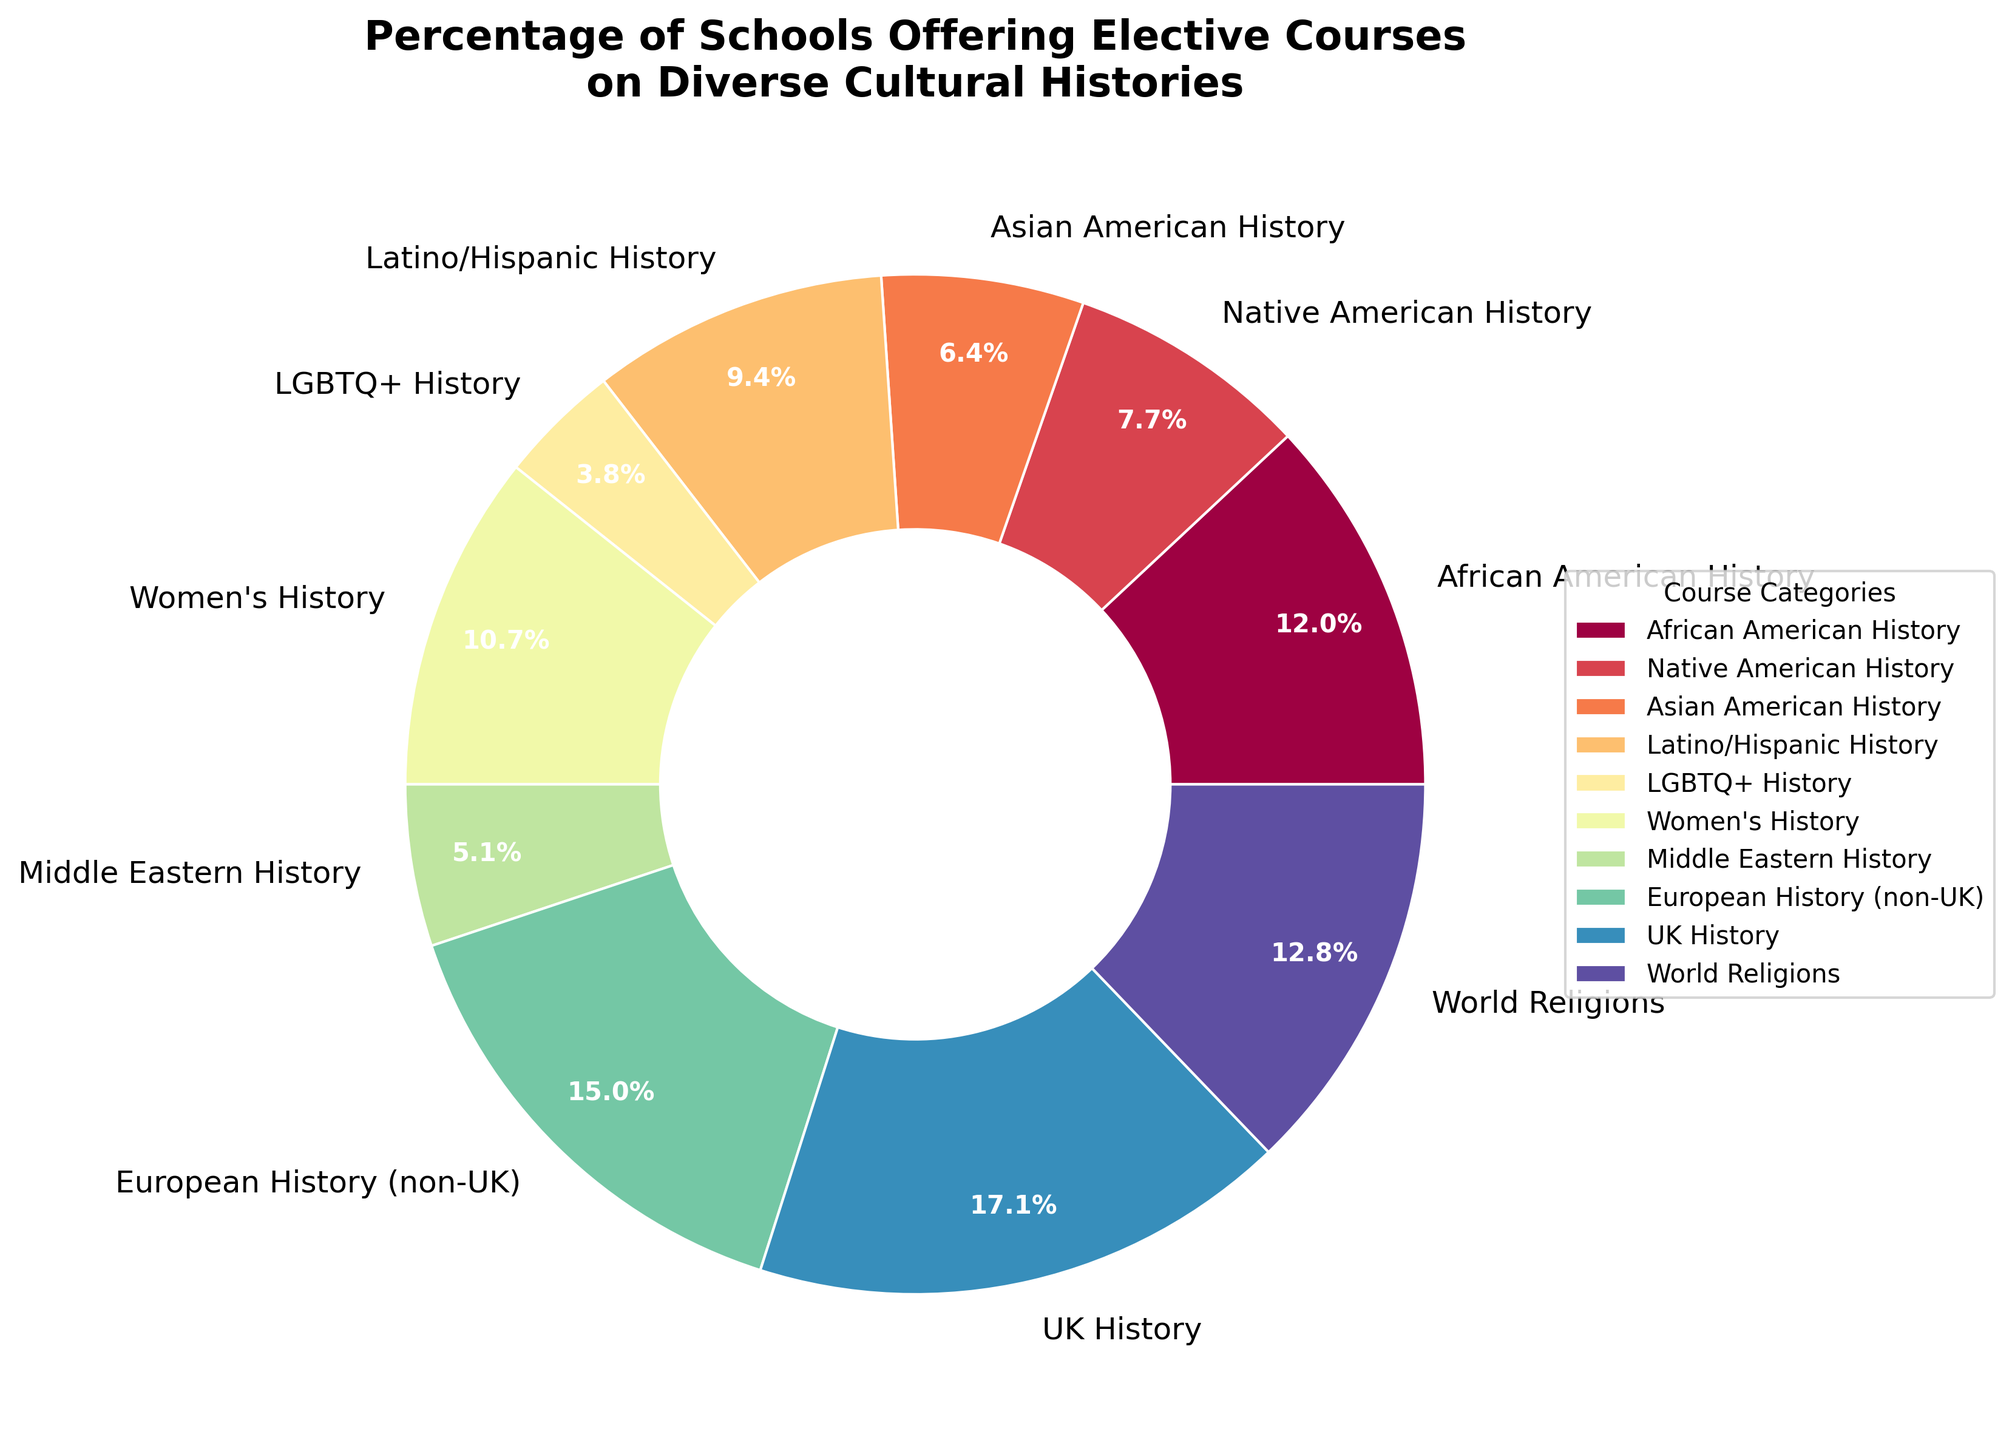Which course category has the highest percentage of schools offering it? By looking at the pie chart, we can see the segment with the largest size represents the highest percentage. In this case, the "UK History" segment seems the largest.
Answer: UK History Which two course categories have the closest percentages? By comparing the size of the segments, "Middle Eastern History" (12%) and "Asian American History" (15%) have the closest percentages.
Answer: Middle Eastern History and Asian American History What is the difference in percentage between African American History and Native American History? The percentage for African American History is 28% and for Native American History is 18%. Subtracting 18% from 28% gives us the difference.
Answer: 10% Add up the percentages of schools offering African American History, Latino/Hispanic History, and Women's History courses. African American History is 28%, Latino/Hispanic History is 22%, and Women's History is 25%. Adding these percentages together: 28% + 22% + 25% = 75%.
Answer: 75% Which category has a higher percentage: World Religions or LGBTQ+ History? And by how much? The pie chart shows World Religions at 30% and LGBTQ+ History at 9%. The difference is 30% - 9%.
Answer: World Religions by 21% What is the combined percentage of schools offering European History (non-UK) and UK History courses? European History (non-UK) is 35% and UK History is 40%. Adding these together gives: 35% + 40% = 75%.
Answer: 75% Which category has the second-highest percentage of schools offering it? First, identify the highest percentage (UK History at 40%), then find the second largest segment. European History (non-UK) at 35% is second.
Answer: European History (non-UK) Are there more schools offering Asian American History or Women's History courses? By looking at the pie chart, Asian American History is at 15% while Women's History is at 25%, so Women's History is greater.
Answer: Women's History What course categories together add up to roughly 50%? By adding percentages of categories, we get close to 50% with African American History (28%) and Native American History (18%): 28% + 18% = 46%. Adjusting by including or adding small categories, African American History (28%) and Middle Eastern History (12%) can be a close approximation: 28% + 12% = 40%.
Answer: African American History and Native American History, or African American History and Middle Eastern History What is the total percentage of schools offering courses on minority group histories (African American, Native American, Asian American, Latino/Hispanic, LGBTQ+)? Add percentages for these categories: African American (28%), Native American (18%), Asian American (15%), Latino/Hispanic (22%), LGBTQ+ History (9%). Total is: 28% + 18% + 15% + 22% + 9% = 92%.
Answer: 92% 